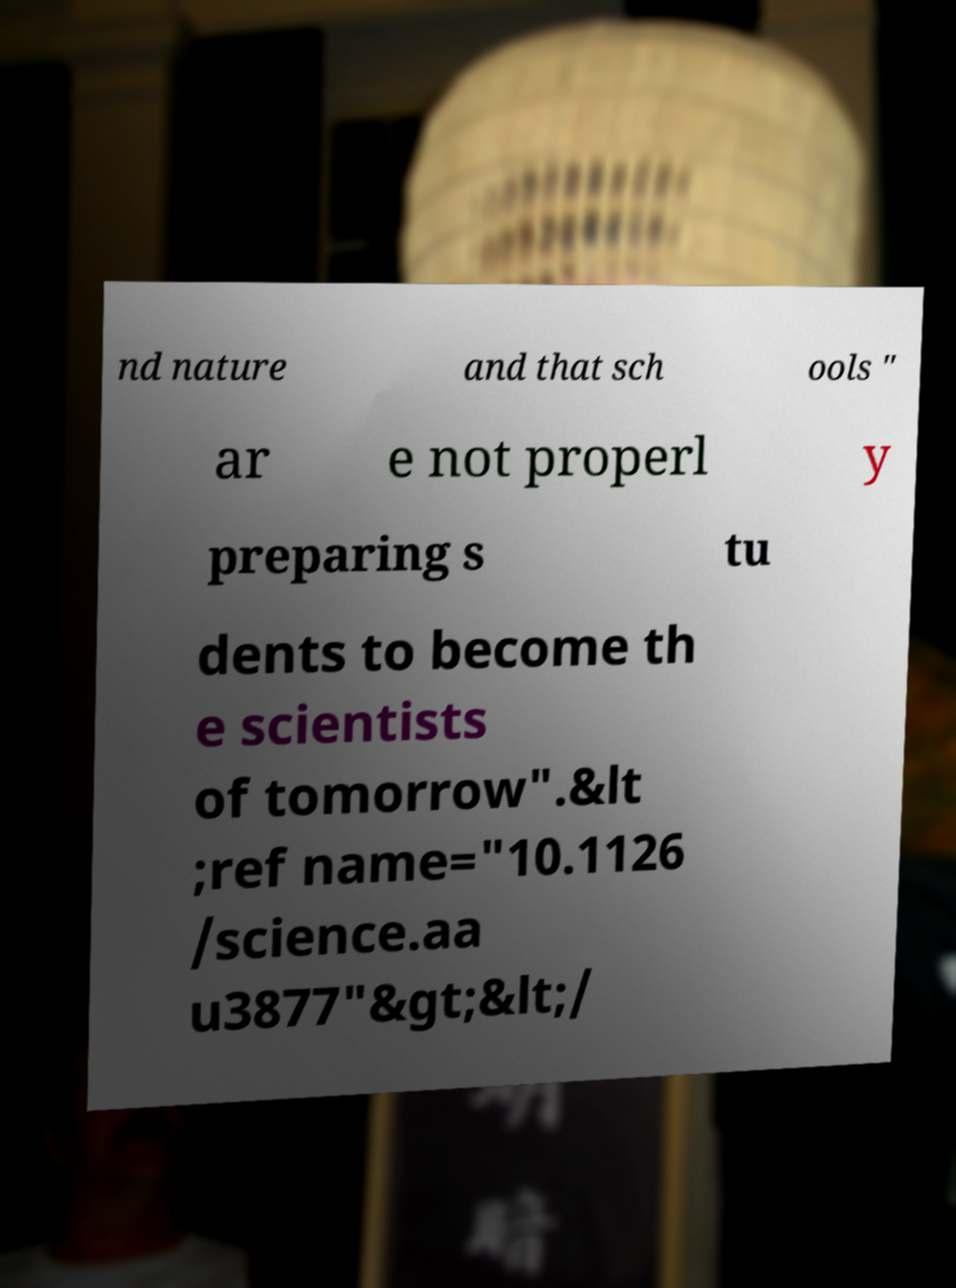Can you accurately transcribe the text from the provided image for me? nd nature and that sch ools " ar e not properl y preparing s tu dents to become th e scientists of tomorrow".&lt ;ref name="10.1126 /science.aa u3877"&gt;&lt;/ 